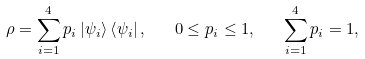<formula> <loc_0><loc_0><loc_500><loc_500>\rho = \sum _ { i = 1 } ^ { 4 } p _ { i } \left | \psi _ { i } \right > \left < \psi _ { i } \right | , \quad 0 \leq p _ { i } \leq 1 , \quad \sum _ { i = 1 } ^ { 4 } p _ { i } = 1 ,</formula> 